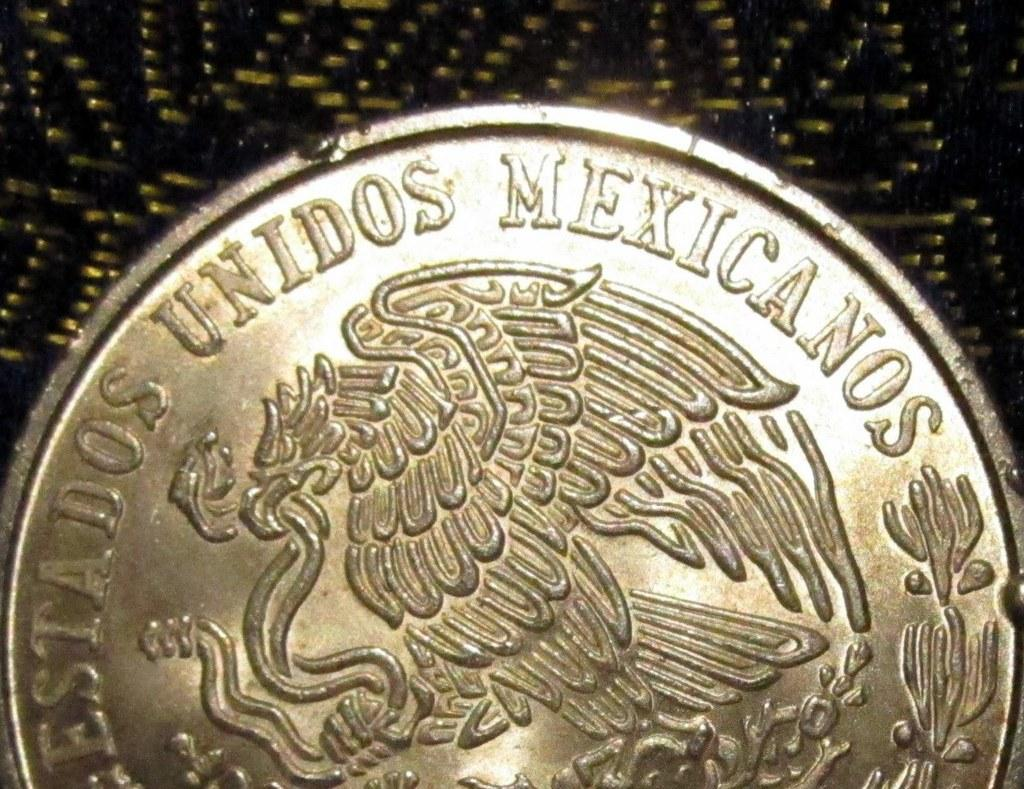<image>
Offer a succinct explanation of the picture presented. A shiny silver coin from the Unidos Mexicanos 